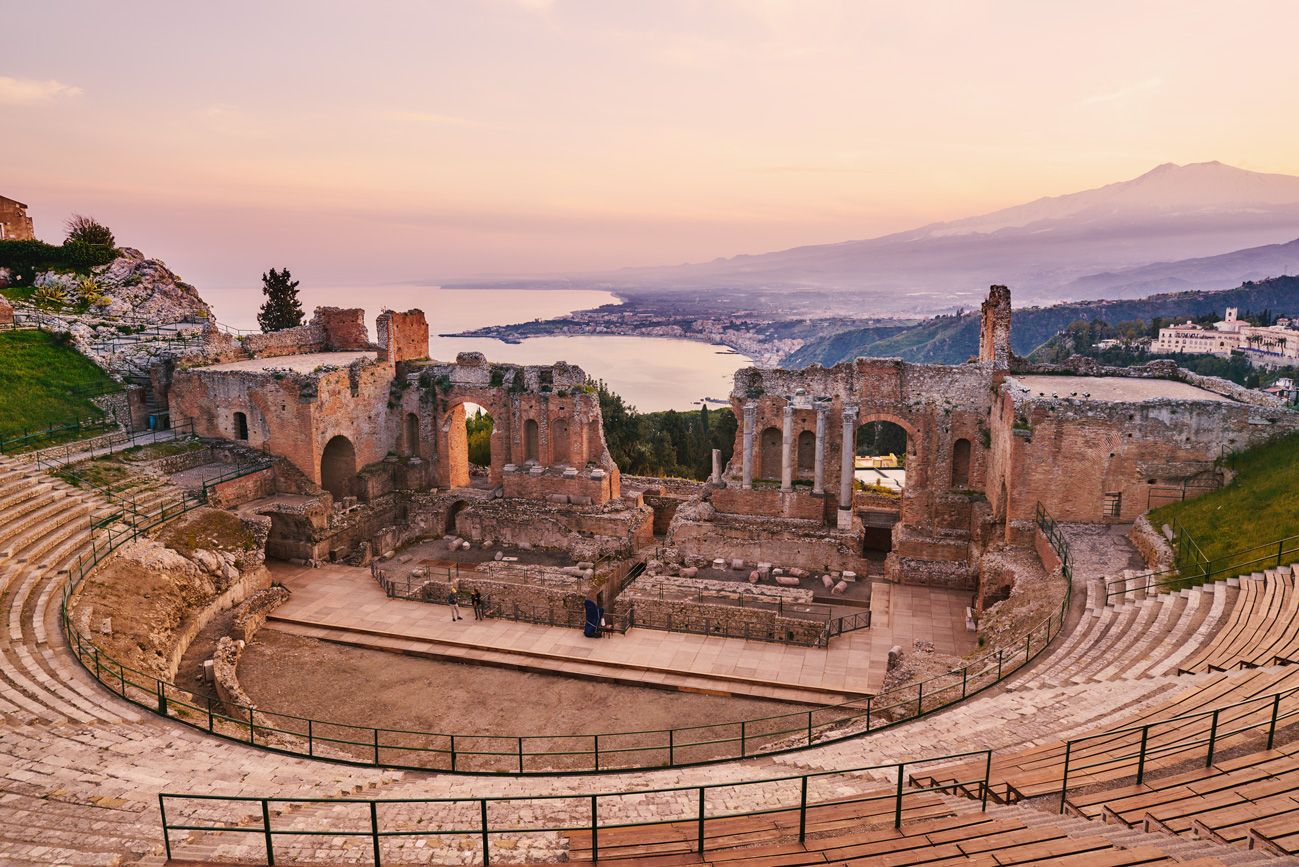What do you think is going on in this snapshot? This snapshot captures a serene moment at the ancient Greek theater in Taormina, Italy, just at either sunrise or sunset, given the soft lighting. The historic site overlooks a breathtaking vista of the Mediterranean Sea with the legendary Mount Etna in the distance, under a hazy sky that suggests an early morning or evening atmosphere. Although the theater is devoid of an audience, its grandeur is palpable, and one can almost hear the echoes of performances past. A few visitors can be seen exploring the ruins, giving the place a sense of continuity and living history. 